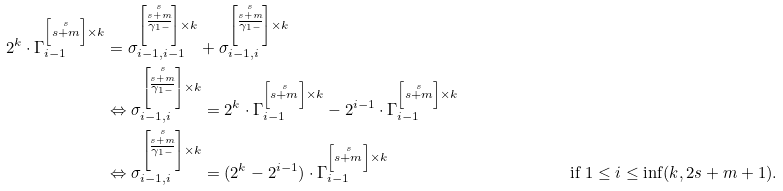<formula> <loc_0><loc_0><loc_500><loc_500>2 ^ { k } \cdot \Gamma _ { i - 1 } ^ { \left [ \stackrel { s } { s + m } \right ] \times k } & = \sigma _ { i - 1 , i - 1 } ^ { \left [ \stackrel { s } { \stackrel { s + m } { \overline { \gamma _ { 1 - } } } } \right ] \times k } + \sigma _ { i - 1 , i } ^ { \left [ \stackrel { s } { \stackrel { s + m } { \overline { \gamma _ { 1 - } } } } \right ] \times k } \\ & \Leftrightarrow \sigma _ { i - 1 , i } ^ { \left [ \stackrel { s } { \stackrel { s + m } { \overline { \gamma _ { 1 - } } } } \right ] \times k } = 2 ^ { k } \cdot \Gamma _ { i - 1 } ^ { \left [ \stackrel { s } { s + m } \right ] \times k } - 2 ^ { i - 1 } \cdot \Gamma _ { i - 1 } ^ { \left [ \stackrel { s } { s + m } \right ] \times k } \\ & \Leftrightarrow \sigma _ { i - 1 , i } ^ { \left [ \stackrel { s } { \stackrel { s + m } { \overline { \gamma _ { 1 - } } } } \right ] \times k } = ( 2 ^ { k } - 2 ^ { i - 1 } ) \cdot \Gamma _ { i - 1 } ^ { \left [ \stackrel { s } { s + m } \right ] \times k } & & \text {if } 1 \leq i \leq \inf ( k , 2 s + m + 1 ) .</formula> 